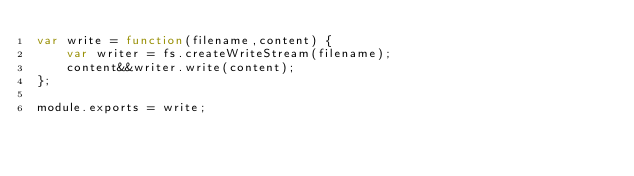<code> <loc_0><loc_0><loc_500><loc_500><_JavaScript_>var write = function(filename,content) {
		var writer = fs.createWriteStream(filename);
		content&&writer.write(content);
};

module.exports = write;</code> 